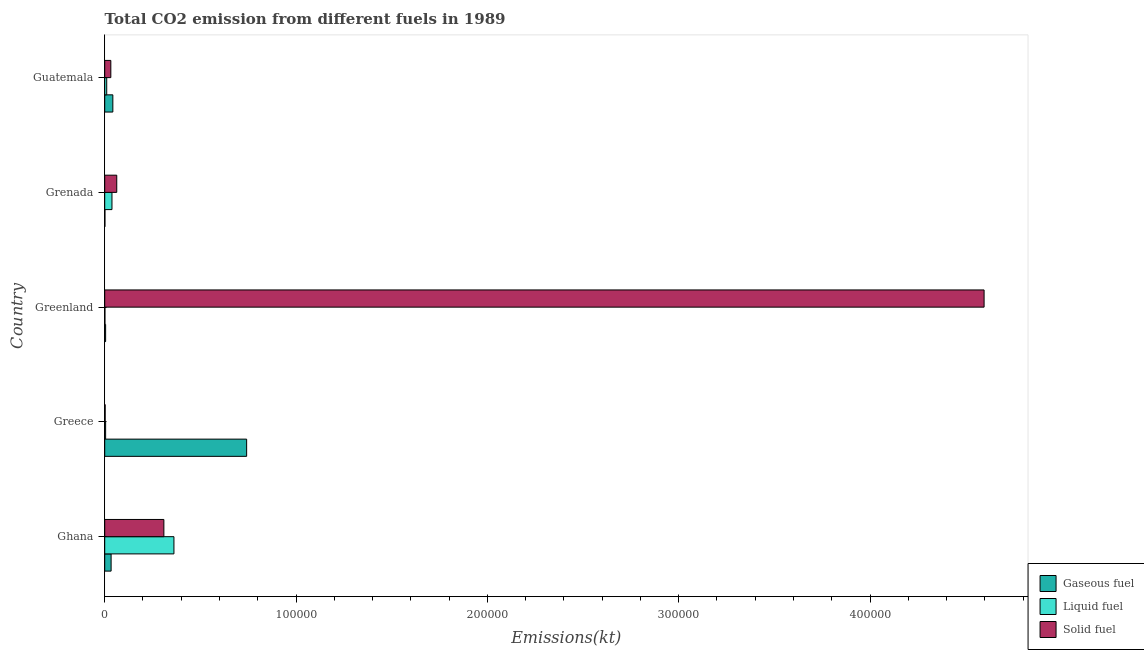How many different coloured bars are there?
Your answer should be compact. 3. Are the number of bars per tick equal to the number of legend labels?
Ensure brevity in your answer.  Yes. Are the number of bars on each tick of the Y-axis equal?
Ensure brevity in your answer.  Yes. How many bars are there on the 3rd tick from the top?
Ensure brevity in your answer.  3. What is the amount of co2 emissions from liquid fuel in Ghana?
Provide a succinct answer. 3.62e+04. Across all countries, what is the maximum amount of co2 emissions from liquid fuel?
Keep it short and to the point. 3.62e+04. Across all countries, what is the minimum amount of co2 emissions from liquid fuel?
Your answer should be compact. 102.68. In which country was the amount of co2 emissions from liquid fuel maximum?
Offer a very short reply. Ghana. In which country was the amount of co2 emissions from liquid fuel minimum?
Keep it short and to the point. Greenland. What is the total amount of co2 emissions from solid fuel in the graph?
Give a very brief answer. 5.00e+05. What is the difference between the amount of co2 emissions from solid fuel in Greenland and that in Guatemala?
Give a very brief answer. 4.56e+05. What is the difference between the amount of co2 emissions from gaseous fuel in Guatemala and the amount of co2 emissions from solid fuel in Greece?
Provide a succinct answer. 4011.7. What is the average amount of co2 emissions from solid fuel per country?
Your answer should be compact. 1.00e+05. What is the difference between the amount of co2 emissions from gaseous fuel and amount of co2 emissions from liquid fuel in Grenada?
Keep it short and to the point. -3685.34. What is the ratio of the amount of co2 emissions from liquid fuel in Grenada to that in Guatemala?
Your answer should be very brief. 3.62. Is the amount of co2 emissions from solid fuel in Ghana less than that in Greece?
Provide a succinct answer. No. Is the difference between the amount of co2 emissions from solid fuel in Greece and Greenland greater than the difference between the amount of co2 emissions from gaseous fuel in Greece and Greenland?
Give a very brief answer. No. What is the difference between the highest and the second highest amount of co2 emissions from gaseous fuel?
Your response must be concise. 6.99e+04. What is the difference between the highest and the lowest amount of co2 emissions from gaseous fuel?
Give a very brief answer. 7.41e+04. Is the sum of the amount of co2 emissions from liquid fuel in Ghana and Grenada greater than the maximum amount of co2 emissions from gaseous fuel across all countries?
Your answer should be compact. No. What does the 3rd bar from the top in Guatemala represents?
Ensure brevity in your answer.  Gaseous fuel. What does the 3rd bar from the bottom in Ghana represents?
Keep it short and to the point. Solid fuel. What is the difference between two consecutive major ticks on the X-axis?
Offer a terse response. 1.00e+05. Does the graph contain grids?
Keep it short and to the point. No. Where does the legend appear in the graph?
Offer a terse response. Bottom right. How are the legend labels stacked?
Your response must be concise. Vertical. What is the title of the graph?
Keep it short and to the point. Total CO2 emission from different fuels in 1989. Does "Total employers" appear as one of the legend labels in the graph?
Give a very brief answer. No. What is the label or title of the X-axis?
Offer a terse response. Emissions(kt). What is the label or title of the Y-axis?
Offer a very short reply. Country. What is the Emissions(kt) of Gaseous fuel in Ghana?
Provide a succinct answer. 3344.3. What is the Emissions(kt) of Liquid fuel in Ghana?
Your answer should be compact. 3.62e+04. What is the Emissions(kt) in Solid fuel in Ghana?
Your response must be concise. 3.09e+04. What is the Emissions(kt) in Gaseous fuel in Greece?
Offer a very short reply. 7.42e+04. What is the Emissions(kt) of Liquid fuel in Greece?
Offer a terse response. 473.04. What is the Emissions(kt) of Solid fuel in Greece?
Your response must be concise. 234.69. What is the Emissions(kt) of Gaseous fuel in Greenland?
Provide a short and direct response. 473.04. What is the Emissions(kt) in Liquid fuel in Greenland?
Provide a succinct answer. 102.68. What is the Emissions(kt) of Solid fuel in Greenland?
Provide a short and direct response. 4.60e+05. What is the Emissions(kt) of Gaseous fuel in Grenada?
Your answer should be compact. 102.68. What is the Emissions(kt) of Liquid fuel in Grenada?
Your answer should be compact. 3788.01. What is the Emissions(kt) of Solid fuel in Grenada?
Ensure brevity in your answer.  6285.24. What is the Emissions(kt) in Gaseous fuel in Guatemala?
Your answer should be very brief. 4246.39. What is the Emissions(kt) in Liquid fuel in Guatemala?
Offer a very short reply. 1045.1. What is the Emissions(kt) of Solid fuel in Guatemala?
Give a very brief answer. 3197.62. Across all countries, what is the maximum Emissions(kt) of Gaseous fuel?
Keep it short and to the point. 7.42e+04. Across all countries, what is the maximum Emissions(kt) of Liquid fuel?
Your answer should be very brief. 3.62e+04. Across all countries, what is the maximum Emissions(kt) of Solid fuel?
Make the answer very short. 4.60e+05. Across all countries, what is the minimum Emissions(kt) of Gaseous fuel?
Make the answer very short. 102.68. Across all countries, what is the minimum Emissions(kt) in Liquid fuel?
Your response must be concise. 102.68. Across all countries, what is the minimum Emissions(kt) in Solid fuel?
Offer a very short reply. 234.69. What is the total Emissions(kt) in Gaseous fuel in the graph?
Provide a succinct answer. 8.23e+04. What is the total Emissions(kt) in Liquid fuel in the graph?
Your answer should be very brief. 4.16e+04. What is the total Emissions(kt) of Solid fuel in the graph?
Ensure brevity in your answer.  5.00e+05. What is the difference between the Emissions(kt) of Gaseous fuel in Ghana and that in Greece?
Make the answer very short. -7.08e+04. What is the difference between the Emissions(kt) in Liquid fuel in Ghana and that in Greece?
Give a very brief answer. 3.57e+04. What is the difference between the Emissions(kt) of Solid fuel in Ghana and that in Greece?
Provide a short and direct response. 3.07e+04. What is the difference between the Emissions(kt) of Gaseous fuel in Ghana and that in Greenland?
Give a very brief answer. 2871.26. What is the difference between the Emissions(kt) in Liquid fuel in Ghana and that in Greenland?
Your answer should be very brief. 3.61e+04. What is the difference between the Emissions(kt) in Solid fuel in Ghana and that in Greenland?
Keep it short and to the point. -4.29e+05. What is the difference between the Emissions(kt) in Gaseous fuel in Ghana and that in Grenada?
Provide a short and direct response. 3241.63. What is the difference between the Emissions(kt) of Liquid fuel in Ghana and that in Grenada?
Offer a very short reply. 3.24e+04. What is the difference between the Emissions(kt) of Solid fuel in Ghana and that in Grenada?
Offer a very short reply. 2.46e+04. What is the difference between the Emissions(kt) of Gaseous fuel in Ghana and that in Guatemala?
Keep it short and to the point. -902.08. What is the difference between the Emissions(kt) of Liquid fuel in Ghana and that in Guatemala?
Ensure brevity in your answer.  3.51e+04. What is the difference between the Emissions(kt) of Solid fuel in Ghana and that in Guatemala?
Offer a very short reply. 2.77e+04. What is the difference between the Emissions(kt) in Gaseous fuel in Greece and that in Greenland?
Make the answer very short. 7.37e+04. What is the difference between the Emissions(kt) of Liquid fuel in Greece and that in Greenland?
Offer a terse response. 370.37. What is the difference between the Emissions(kt) in Solid fuel in Greece and that in Greenland?
Offer a very short reply. -4.59e+05. What is the difference between the Emissions(kt) of Gaseous fuel in Greece and that in Grenada?
Your response must be concise. 7.41e+04. What is the difference between the Emissions(kt) in Liquid fuel in Greece and that in Grenada?
Ensure brevity in your answer.  -3314.97. What is the difference between the Emissions(kt) of Solid fuel in Greece and that in Grenada?
Provide a succinct answer. -6050.55. What is the difference between the Emissions(kt) in Gaseous fuel in Greece and that in Guatemala?
Your answer should be compact. 6.99e+04. What is the difference between the Emissions(kt) in Liquid fuel in Greece and that in Guatemala?
Provide a succinct answer. -572.05. What is the difference between the Emissions(kt) in Solid fuel in Greece and that in Guatemala?
Ensure brevity in your answer.  -2962.94. What is the difference between the Emissions(kt) in Gaseous fuel in Greenland and that in Grenada?
Your response must be concise. 370.37. What is the difference between the Emissions(kt) of Liquid fuel in Greenland and that in Grenada?
Your answer should be compact. -3685.34. What is the difference between the Emissions(kt) in Solid fuel in Greenland and that in Grenada?
Your response must be concise. 4.53e+05. What is the difference between the Emissions(kt) of Gaseous fuel in Greenland and that in Guatemala?
Your response must be concise. -3773.34. What is the difference between the Emissions(kt) in Liquid fuel in Greenland and that in Guatemala?
Give a very brief answer. -942.42. What is the difference between the Emissions(kt) in Solid fuel in Greenland and that in Guatemala?
Offer a very short reply. 4.56e+05. What is the difference between the Emissions(kt) in Gaseous fuel in Grenada and that in Guatemala?
Give a very brief answer. -4143.71. What is the difference between the Emissions(kt) of Liquid fuel in Grenada and that in Guatemala?
Make the answer very short. 2742.92. What is the difference between the Emissions(kt) of Solid fuel in Grenada and that in Guatemala?
Provide a succinct answer. 3087.61. What is the difference between the Emissions(kt) of Gaseous fuel in Ghana and the Emissions(kt) of Liquid fuel in Greece?
Provide a short and direct response. 2871.26. What is the difference between the Emissions(kt) of Gaseous fuel in Ghana and the Emissions(kt) of Solid fuel in Greece?
Your answer should be compact. 3109.62. What is the difference between the Emissions(kt) in Liquid fuel in Ghana and the Emissions(kt) in Solid fuel in Greece?
Provide a short and direct response. 3.59e+04. What is the difference between the Emissions(kt) in Gaseous fuel in Ghana and the Emissions(kt) in Liquid fuel in Greenland?
Your answer should be compact. 3241.63. What is the difference between the Emissions(kt) in Gaseous fuel in Ghana and the Emissions(kt) in Solid fuel in Greenland?
Your response must be concise. -4.56e+05. What is the difference between the Emissions(kt) in Liquid fuel in Ghana and the Emissions(kt) in Solid fuel in Greenland?
Offer a very short reply. -4.23e+05. What is the difference between the Emissions(kt) of Gaseous fuel in Ghana and the Emissions(kt) of Liquid fuel in Grenada?
Your answer should be compact. -443.71. What is the difference between the Emissions(kt) in Gaseous fuel in Ghana and the Emissions(kt) in Solid fuel in Grenada?
Provide a succinct answer. -2940.93. What is the difference between the Emissions(kt) in Liquid fuel in Ghana and the Emissions(kt) in Solid fuel in Grenada?
Give a very brief answer. 2.99e+04. What is the difference between the Emissions(kt) in Gaseous fuel in Ghana and the Emissions(kt) in Liquid fuel in Guatemala?
Make the answer very short. 2299.21. What is the difference between the Emissions(kt) of Gaseous fuel in Ghana and the Emissions(kt) of Solid fuel in Guatemala?
Ensure brevity in your answer.  146.68. What is the difference between the Emissions(kt) of Liquid fuel in Ghana and the Emissions(kt) of Solid fuel in Guatemala?
Offer a terse response. 3.30e+04. What is the difference between the Emissions(kt) in Gaseous fuel in Greece and the Emissions(kt) in Liquid fuel in Greenland?
Make the answer very short. 7.41e+04. What is the difference between the Emissions(kt) of Gaseous fuel in Greece and the Emissions(kt) of Solid fuel in Greenland?
Give a very brief answer. -3.85e+05. What is the difference between the Emissions(kt) of Liquid fuel in Greece and the Emissions(kt) of Solid fuel in Greenland?
Your answer should be compact. -4.59e+05. What is the difference between the Emissions(kt) in Gaseous fuel in Greece and the Emissions(kt) in Liquid fuel in Grenada?
Make the answer very short. 7.04e+04. What is the difference between the Emissions(kt) in Gaseous fuel in Greece and the Emissions(kt) in Solid fuel in Grenada?
Provide a short and direct response. 6.79e+04. What is the difference between the Emissions(kt) in Liquid fuel in Greece and the Emissions(kt) in Solid fuel in Grenada?
Give a very brief answer. -5812.19. What is the difference between the Emissions(kt) of Gaseous fuel in Greece and the Emissions(kt) of Liquid fuel in Guatemala?
Offer a terse response. 7.31e+04. What is the difference between the Emissions(kt) of Gaseous fuel in Greece and the Emissions(kt) of Solid fuel in Guatemala?
Your answer should be compact. 7.10e+04. What is the difference between the Emissions(kt) of Liquid fuel in Greece and the Emissions(kt) of Solid fuel in Guatemala?
Provide a succinct answer. -2724.58. What is the difference between the Emissions(kt) in Gaseous fuel in Greenland and the Emissions(kt) in Liquid fuel in Grenada?
Keep it short and to the point. -3314.97. What is the difference between the Emissions(kt) in Gaseous fuel in Greenland and the Emissions(kt) in Solid fuel in Grenada?
Keep it short and to the point. -5812.19. What is the difference between the Emissions(kt) in Liquid fuel in Greenland and the Emissions(kt) in Solid fuel in Grenada?
Keep it short and to the point. -6182.56. What is the difference between the Emissions(kt) in Gaseous fuel in Greenland and the Emissions(kt) in Liquid fuel in Guatemala?
Your answer should be very brief. -572.05. What is the difference between the Emissions(kt) of Gaseous fuel in Greenland and the Emissions(kt) of Solid fuel in Guatemala?
Your answer should be compact. -2724.58. What is the difference between the Emissions(kt) in Liquid fuel in Greenland and the Emissions(kt) in Solid fuel in Guatemala?
Ensure brevity in your answer.  -3094.95. What is the difference between the Emissions(kt) of Gaseous fuel in Grenada and the Emissions(kt) of Liquid fuel in Guatemala?
Your answer should be compact. -942.42. What is the difference between the Emissions(kt) of Gaseous fuel in Grenada and the Emissions(kt) of Solid fuel in Guatemala?
Provide a succinct answer. -3094.95. What is the difference between the Emissions(kt) in Liquid fuel in Grenada and the Emissions(kt) in Solid fuel in Guatemala?
Your answer should be compact. 590.39. What is the average Emissions(kt) of Gaseous fuel per country?
Offer a very short reply. 1.65e+04. What is the average Emissions(kt) of Liquid fuel per country?
Your response must be concise. 8318.22. What is the average Emissions(kt) in Solid fuel per country?
Provide a succinct answer. 1.00e+05. What is the difference between the Emissions(kt) in Gaseous fuel and Emissions(kt) in Liquid fuel in Ghana?
Your answer should be very brief. -3.28e+04. What is the difference between the Emissions(kt) in Gaseous fuel and Emissions(kt) in Solid fuel in Ghana?
Provide a succinct answer. -2.76e+04. What is the difference between the Emissions(kt) of Liquid fuel and Emissions(kt) of Solid fuel in Ghana?
Give a very brief answer. 5265.81. What is the difference between the Emissions(kt) in Gaseous fuel and Emissions(kt) in Liquid fuel in Greece?
Offer a very short reply. 7.37e+04. What is the difference between the Emissions(kt) of Gaseous fuel and Emissions(kt) of Solid fuel in Greece?
Your answer should be compact. 7.39e+04. What is the difference between the Emissions(kt) in Liquid fuel and Emissions(kt) in Solid fuel in Greece?
Provide a succinct answer. 238.35. What is the difference between the Emissions(kt) in Gaseous fuel and Emissions(kt) in Liquid fuel in Greenland?
Provide a succinct answer. 370.37. What is the difference between the Emissions(kt) of Gaseous fuel and Emissions(kt) of Solid fuel in Greenland?
Provide a short and direct response. -4.59e+05. What is the difference between the Emissions(kt) in Liquid fuel and Emissions(kt) in Solid fuel in Greenland?
Keep it short and to the point. -4.60e+05. What is the difference between the Emissions(kt) in Gaseous fuel and Emissions(kt) in Liquid fuel in Grenada?
Provide a short and direct response. -3685.34. What is the difference between the Emissions(kt) in Gaseous fuel and Emissions(kt) in Solid fuel in Grenada?
Ensure brevity in your answer.  -6182.56. What is the difference between the Emissions(kt) of Liquid fuel and Emissions(kt) of Solid fuel in Grenada?
Provide a short and direct response. -2497.23. What is the difference between the Emissions(kt) of Gaseous fuel and Emissions(kt) of Liquid fuel in Guatemala?
Your response must be concise. 3201.29. What is the difference between the Emissions(kt) in Gaseous fuel and Emissions(kt) in Solid fuel in Guatemala?
Offer a very short reply. 1048.76. What is the difference between the Emissions(kt) in Liquid fuel and Emissions(kt) in Solid fuel in Guatemala?
Your answer should be compact. -2152.53. What is the ratio of the Emissions(kt) of Gaseous fuel in Ghana to that in Greece?
Give a very brief answer. 0.05. What is the ratio of the Emissions(kt) in Liquid fuel in Ghana to that in Greece?
Offer a terse response. 76.49. What is the ratio of the Emissions(kt) of Solid fuel in Ghana to that in Greece?
Ensure brevity in your answer.  131.73. What is the ratio of the Emissions(kt) in Gaseous fuel in Ghana to that in Greenland?
Make the answer very short. 7.07. What is the ratio of the Emissions(kt) in Liquid fuel in Ghana to that in Greenland?
Your response must be concise. 352.39. What is the ratio of the Emissions(kt) of Solid fuel in Ghana to that in Greenland?
Your answer should be compact. 0.07. What is the ratio of the Emissions(kt) in Gaseous fuel in Ghana to that in Grenada?
Offer a terse response. 32.57. What is the ratio of the Emissions(kt) of Liquid fuel in Ghana to that in Grenada?
Ensure brevity in your answer.  9.55. What is the ratio of the Emissions(kt) of Solid fuel in Ghana to that in Grenada?
Make the answer very short. 4.92. What is the ratio of the Emissions(kt) of Gaseous fuel in Ghana to that in Guatemala?
Your answer should be compact. 0.79. What is the ratio of the Emissions(kt) of Liquid fuel in Ghana to that in Guatemala?
Offer a very short reply. 34.62. What is the ratio of the Emissions(kt) of Solid fuel in Ghana to that in Guatemala?
Offer a very short reply. 9.67. What is the ratio of the Emissions(kt) in Gaseous fuel in Greece to that in Greenland?
Offer a very short reply. 156.82. What is the ratio of the Emissions(kt) of Liquid fuel in Greece to that in Greenland?
Ensure brevity in your answer.  4.61. What is the ratio of the Emissions(kt) of Gaseous fuel in Greece to that in Grenada?
Your answer should be very brief. 722.5. What is the ratio of the Emissions(kt) of Liquid fuel in Greece to that in Grenada?
Provide a succinct answer. 0.12. What is the ratio of the Emissions(kt) of Solid fuel in Greece to that in Grenada?
Give a very brief answer. 0.04. What is the ratio of the Emissions(kt) of Gaseous fuel in Greece to that in Guatemala?
Provide a short and direct response. 17.47. What is the ratio of the Emissions(kt) of Liquid fuel in Greece to that in Guatemala?
Offer a terse response. 0.45. What is the ratio of the Emissions(kt) in Solid fuel in Greece to that in Guatemala?
Offer a terse response. 0.07. What is the ratio of the Emissions(kt) of Gaseous fuel in Greenland to that in Grenada?
Your answer should be very brief. 4.61. What is the ratio of the Emissions(kt) of Liquid fuel in Greenland to that in Grenada?
Your response must be concise. 0.03. What is the ratio of the Emissions(kt) in Solid fuel in Greenland to that in Grenada?
Ensure brevity in your answer.  73.13. What is the ratio of the Emissions(kt) of Gaseous fuel in Greenland to that in Guatemala?
Your answer should be very brief. 0.11. What is the ratio of the Emissions(kt) in Liquid fuel in Greenland to that in Guatemala?
Provide a succinct answer. 0.1. What is the ratio of the Emissions(kt) of Solid fuel in Greenland to that in Guatemala?
Your answer should be compact. 143.74. What is the ratio of the Emissions(kt) in Gaseous fuel in Grenada to that in Guatemala?
Ensure brevity in your answer.  0.02. What is the ratio of the Emissions(kt) in Liquid fuel in Grenada to that in Guatemala?
Keep it short and to the point. 3.62. What is the ratio of the Emissions(kt) of Solid fuel in Grenada to that in Guatemala?
Your answer should be compact. 1.97. What is the difference between the highest and the second highest Emissions(kt) in Gaseous fuel?
Ensure brevity in your answer.  6.99e+04. What is the difference between the highest and the second highest Emissions(kt) of Liquid fuel?
Your answer should be very brief. 3.24e+04. What is the difference between the highest and the second highest Emissions(kt) of Solid fuel?
Give a very brief answer. 4.29e+05. What is the difference between the highest and the lowest Emissions(kt) of Gaseous fuel?
Provide a succinct answer. 7.41e+04. What is the difference between the highest and the lowest Emissions(kt) of Liquid fuel?
Provide a short and direct response. 3.61e+04. What is the difference between the highest and the lowest Emissions(kt) of Solid fuel?
Your response must be concise. 4.59e+05. 